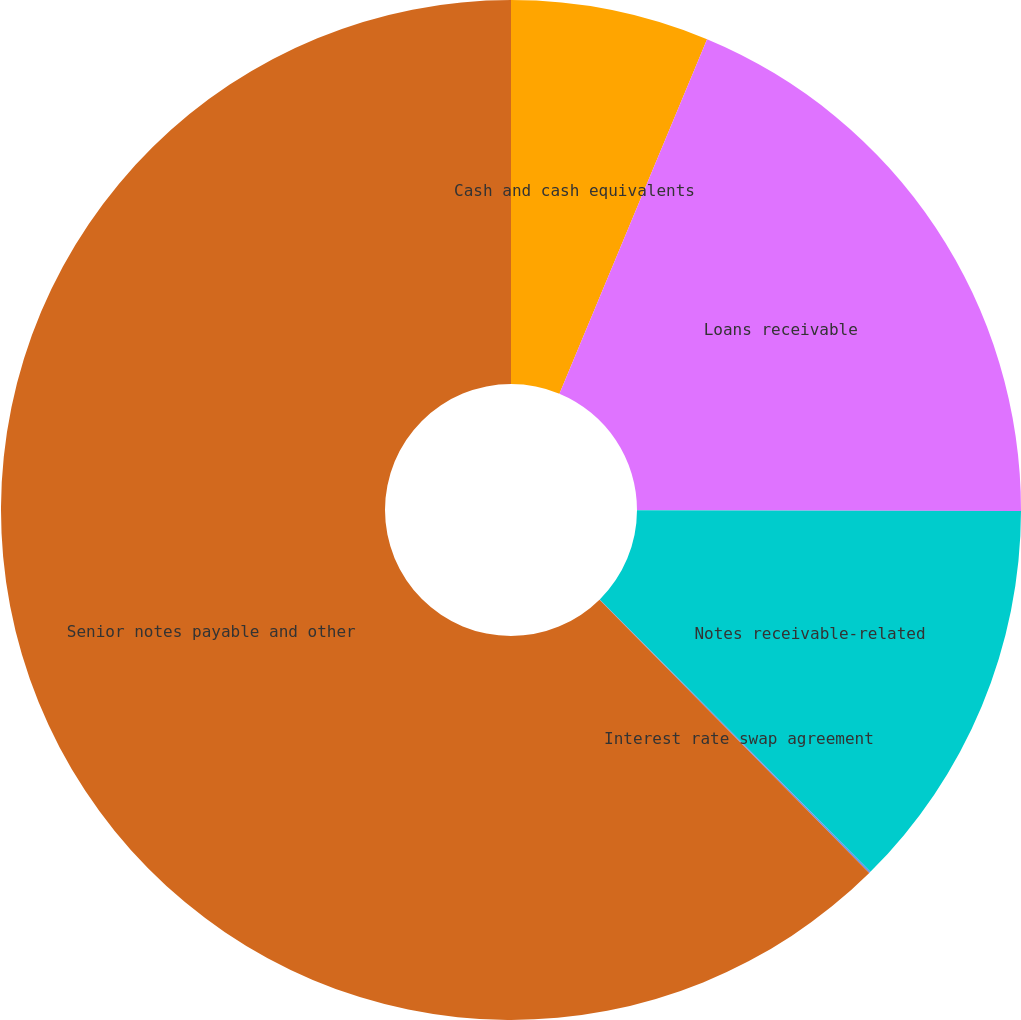Convert chart to OTSL. <chart><loc_0><loc_0><loc_500><loc_500><pie_chart><fcel>Cash and cash equivalents<fcel>Loans receivable<fcel>Notes receivable-related<fcel>Interest rate swap agreement<fcel>Senior notes payable and other<nl><fcel>6.28%<fcel>18.75%<fcel>12.52%<fcel>0.05%<fcel>62.39%<nl></chart> 